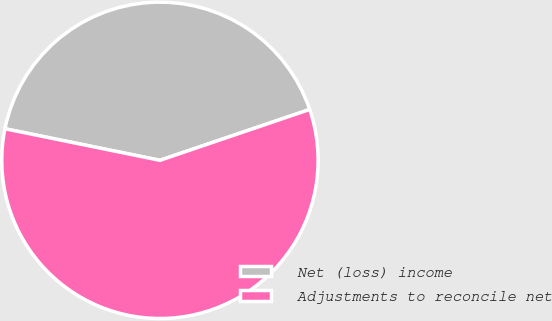Convert chart. <chart><loc_0><loc_0><loc_500><loc_500><pie_chart><fcel>Net (loss) income<fcel>Adjustments to reconcile net<nl><fcel>41.59%<fcel>58.41%<nl></chart> 